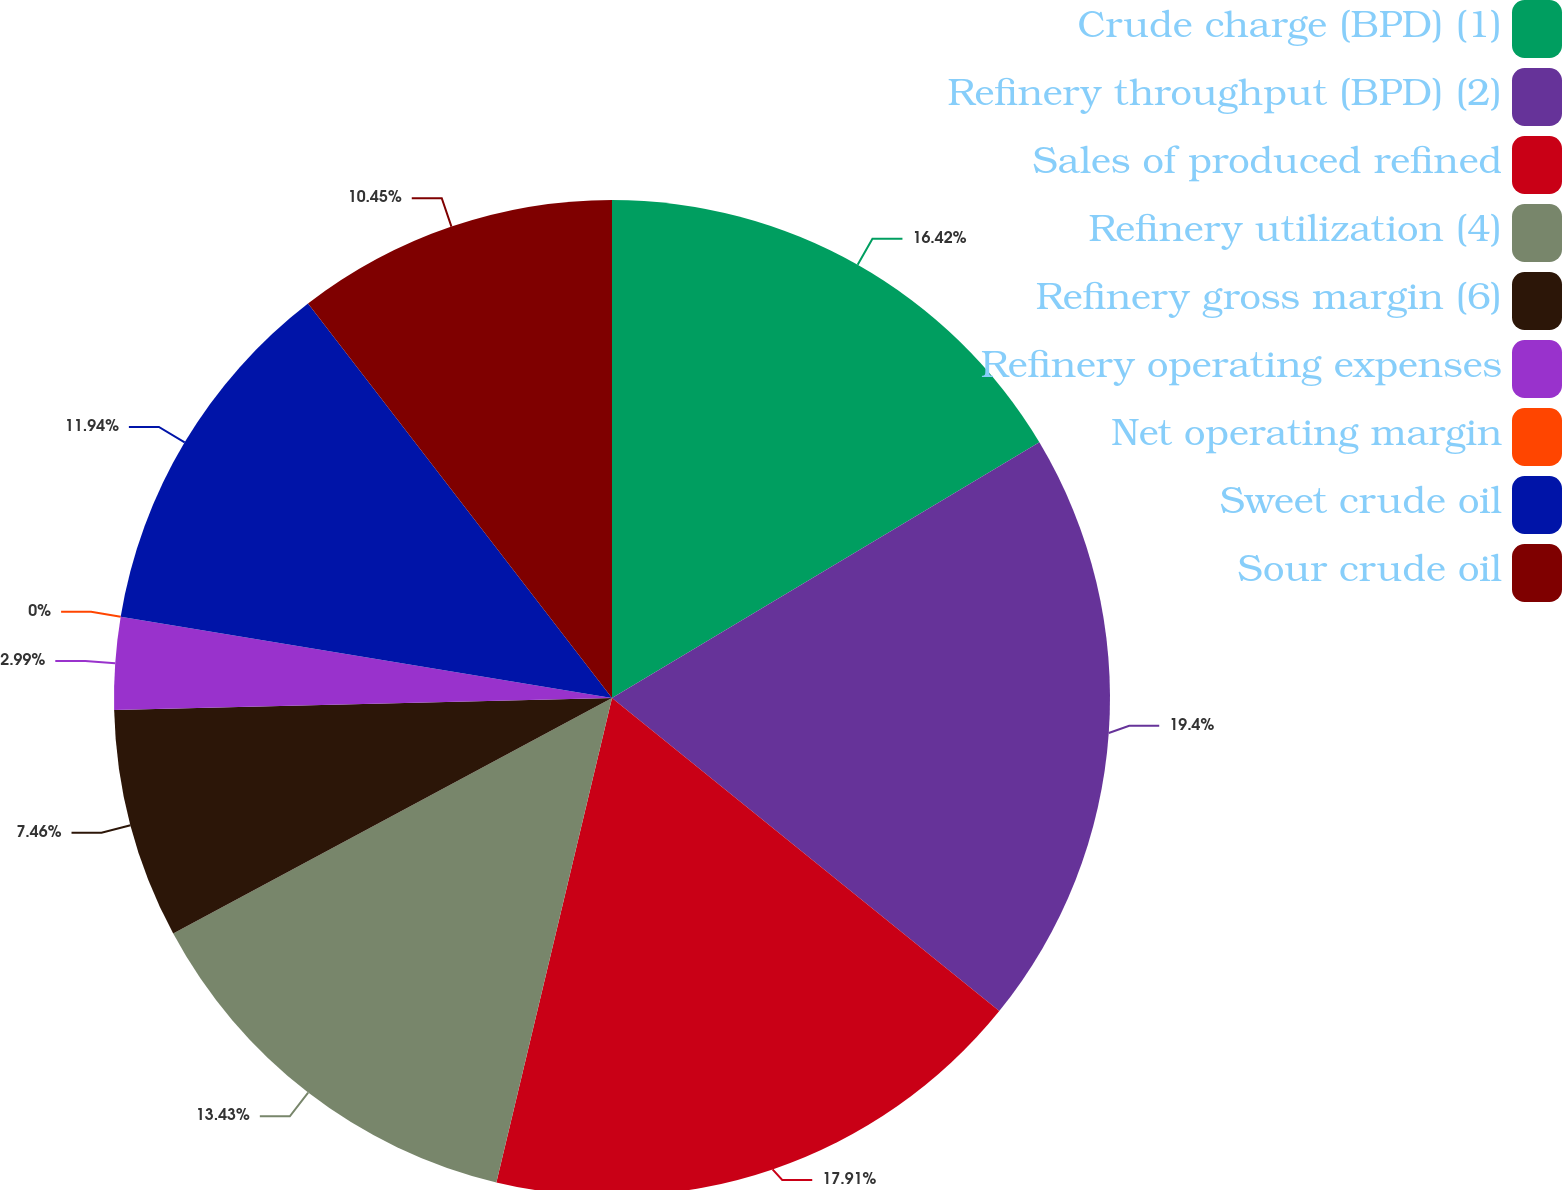<chart> <loc_0><loc_0><loc_500><loc_500><pie_chart><fcel>Crude charge (BPD) (1)<fcel>Refinery throughput (BPD) (2)<fcel>Sales of produced refined<fcel>Refinery utilization (4)<fcel>Refinery gross margin (6)<fcel>Refinery operating expenses<fcel>Net operating margin<fcel>Sweet crude oil<fcel>Sour crude oil<nl><fcel>16.42%<fcel>19.4%<fcel>17.91%<fcel>13.43%<fcel>7.46%<fcel>2.99%<fcel>0.0%<fcel>11.94%<fcel>10.45%<nl></chart> 